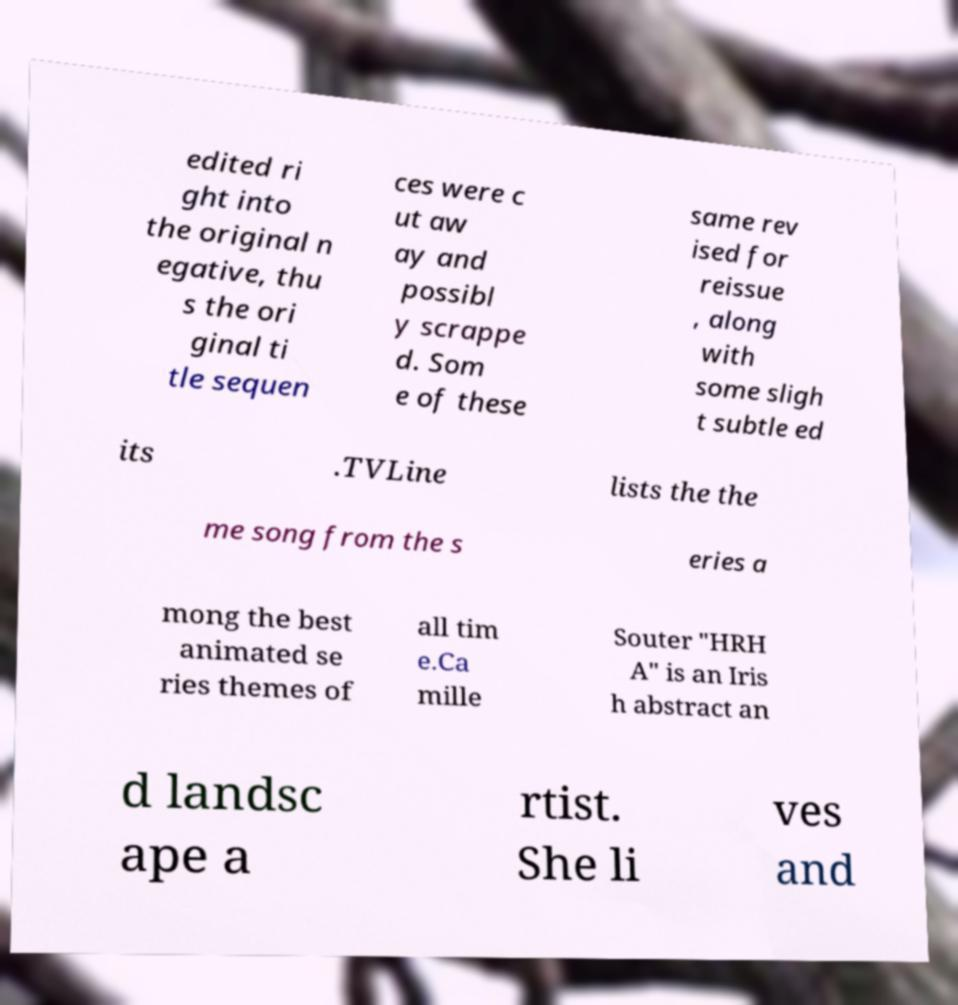I need the written content from this picture converted into text. Can you do that? edited ri ght into the original n egative, thu s the ori ginal ti tle sequen ces were c ut aw ay and possibl y scrappe d. Som e of these same rev ised for reissue , along with some sligh t subtle ed its .TVLine lists the the me song from the s eries a mong the best animated se ries themes of all tim e.Ca mille Souter "HRH A" is an Iris h abstract an d landsc ape a rtist. She li ves and 